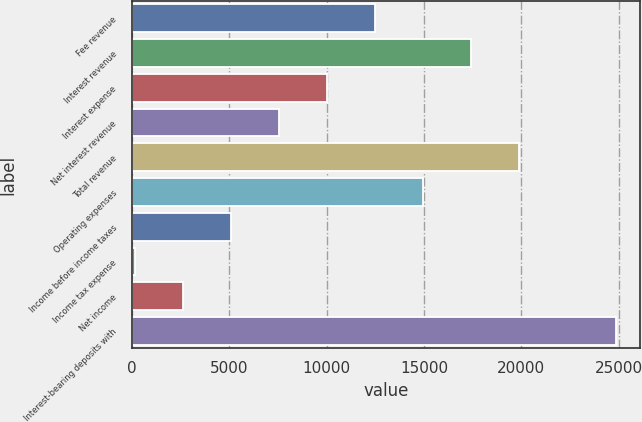<chart> <loc_0><loc_0><loc_500><loc_500><bar_chart><fcel>Fee revenue<fcel>Interest revenue<fcel>Interest expense<fcel>Net interest revenue<fcel>Total revenue<fcel>Operating expenses<fcel>Income before income taxes<fcel>Income tax expense<fcel>Net income<fcel>Interest-bearing deposits with<nl><fcel>12500<fcel>17436.8<fcel>10031.6<fcel>7563.2<fcel>19905.2<fcel>14968.4<fcel>5094.8<fcel>158<fcel>2626.4<fcel>24842<nl></chart> 